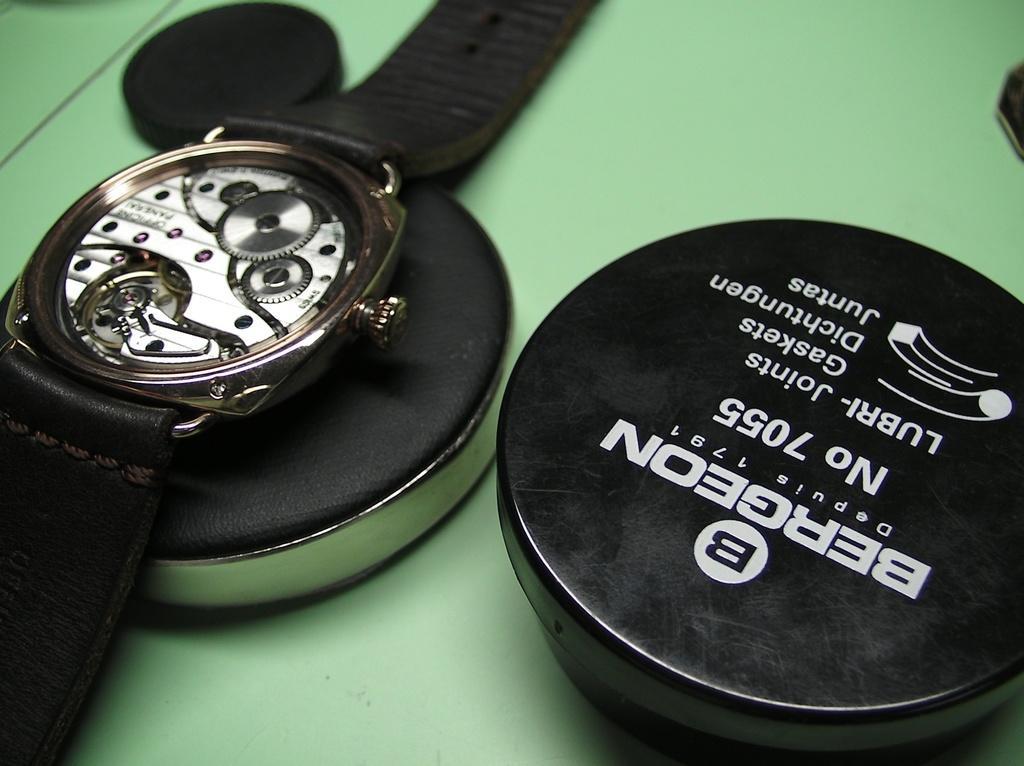Can you describe this image briefly? In this image I can see black colour boxes, a black and white colour watch and here I can see something is written. I can also see one black colour thing in background and I can see this image is little bit blood from background 